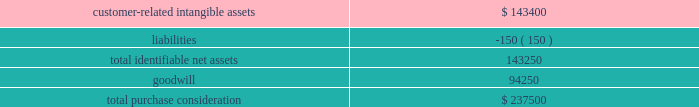Fis gaming business on june 1 , 2015 , we acquired certain assets of certegy check services , inc. , a wholly-owned subsidiary of fidelity national information services , inc .
( 201cfis 201d ) .
Under the purchase arrangement , we acquired substantially all of the assets of its gaming business related to licensed gaming operators ( the 201cfis gaming business 201d ) , including relationships with gaming clients in approximately 260 locations as of the acquisition date , for $ 237.5 million , funded from borrowings on our revolving credit facility and cash on hand .
We acquired the fis gaming business to expand our direct distribution and service offerings in the gaming market .
The estimated acquisition-date fair values of major classes of assets acquired and liabilities assumed , including a reconciliation to the total purchase consideration , were as follows ( in thousands ) : .
Goodwill arising from the acquisition , included in the north america segment , was attributable to an expected growth opportunities , including cross-selling opportunities at existing and acquired gaming client locations and operating synergies in the gaming business , and an assembled workforce .
Goodwill associated with this acquisition is deductible for income tax purposes .
The customer-related intangible assets have an estimated amortization period of 15 years .
Valuation of identified intangible assets for the acquisitions discussed above , the estimated fair values of customer-related intangible assets were determined using the income approach , which was based on projected cash flows discounted to their present value using discount rates that consider the timing and risk of the forecasted cash flows .
The discount rates used represented the average estimated value of a market participant 2019s cost of capital and debt , derived using customary market metrics .
Acquired technologies were valued using the replacement cost method , which required us to estimate the costs to construct an asset of equivalent utility at prices available at the time of the valuation analysis , with adjustments in value for physical deterioration and functional and economic obsolescence .
Trademarks and trade names were valued using the 201crelief-from-royalty 201d approach .
This method assumes that trademarks and trade names have value to the extent that their owner is relieved of the obligation to pay royalties for the benefits received from them .
This method required us to estimate the future revenues for the related brands , the appropriate royalty rate and the weighted-average cost of capital .
The discount rates used represented the average estimated value of a market participant 2019s cost of capital and debt , derived using customary market metrics .
Note 3 2014 revenues we are a leading worldwide provider of payment technology and software solutions delivering innovative services to our customers globally .
Our technologies , services and employee expertise enable us to provide a broad range of solutions that allow our customers to accept various payment types and operate their businesses more efficiently .
We distribute our services across a variety of channels to customers .
The disclosures in this note are applicable for the year ended december 31 , 2018 .
Global payments inc .
| 2018 form 10-k annual report 2013 79 .
What is the goodwill-to-assets ratio? 
Computations: (94250 / 143400)
Answer: 0.65725. 